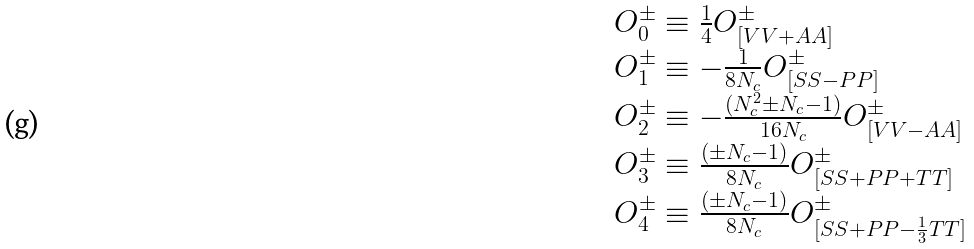<formula> <loc_0><loc_0><loc_500><loc_500>\begin{array} { l } O ^ { \pm } _ { 0 } \equiv \frac { 1 } { 4 } O ^ { \pm } _ { [ V V + A A ] } \\ O ^ { \pm } _ { 1 } \equiv - \frac { 1 } { 8 N _ { c } } O ^ { \pm } _ { [ S S - P P ] } \\ O ^ { \pm } _ { 2 } \equiv - \frac { ( N _ { c } ^ { 2 } \pm N _ { c } - 1 ) } { 1 6 N _ { c } } O ^ { \pm } _ { [ V V - A A ] } \\ O ^ { \pm } _ { 3 } \equiv \frac { ( \pm N _ { c } - 1 ) } { 8 N _ { c } } O ^ { \pm } _ { [ S S + P P + T T ] } \\ O ^ { \pm } _ { 4 } \equiv \frac { ( \pm N _ { c } - 1 ) } { 8 N _ { c } } O ^ { \pm } _ { [ S S + P P - \frac { 1 } { 3 } T T ] } \end{array}</formula> 